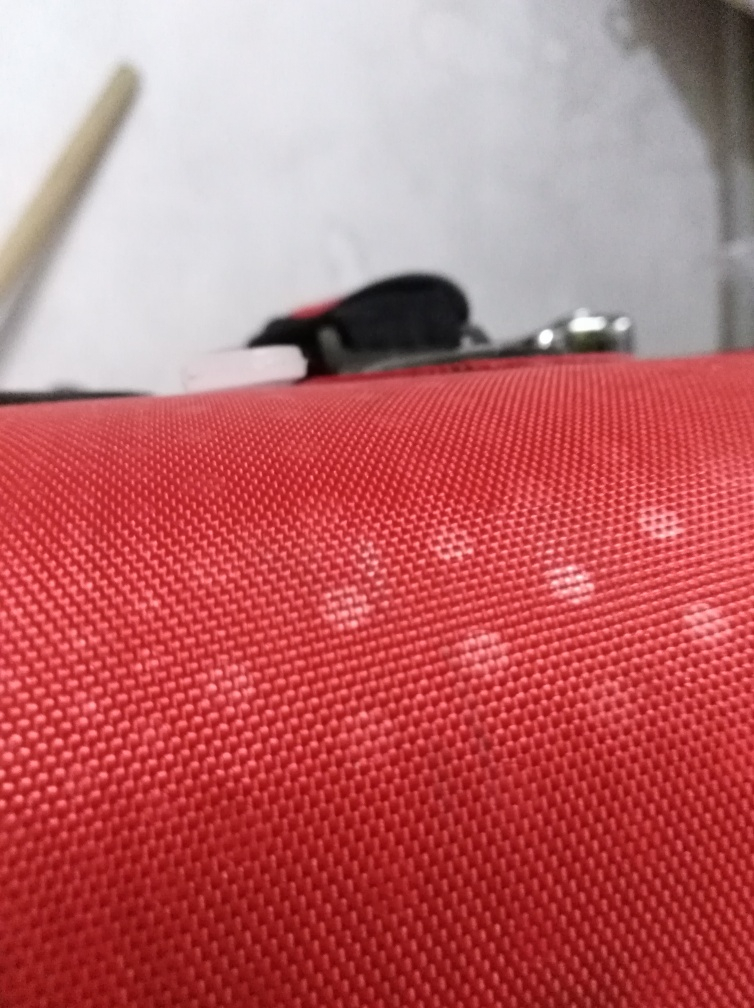What could be the purpose of this image? Given the content and quality of the image, it may not be intended for professional or aesthetic purposes. It might have been taken to document the texture of the material, or perhaps it was snapped accidentally. The lack of focus on a clear subject makes it challenging to determine the photographer's intent without additional context. 